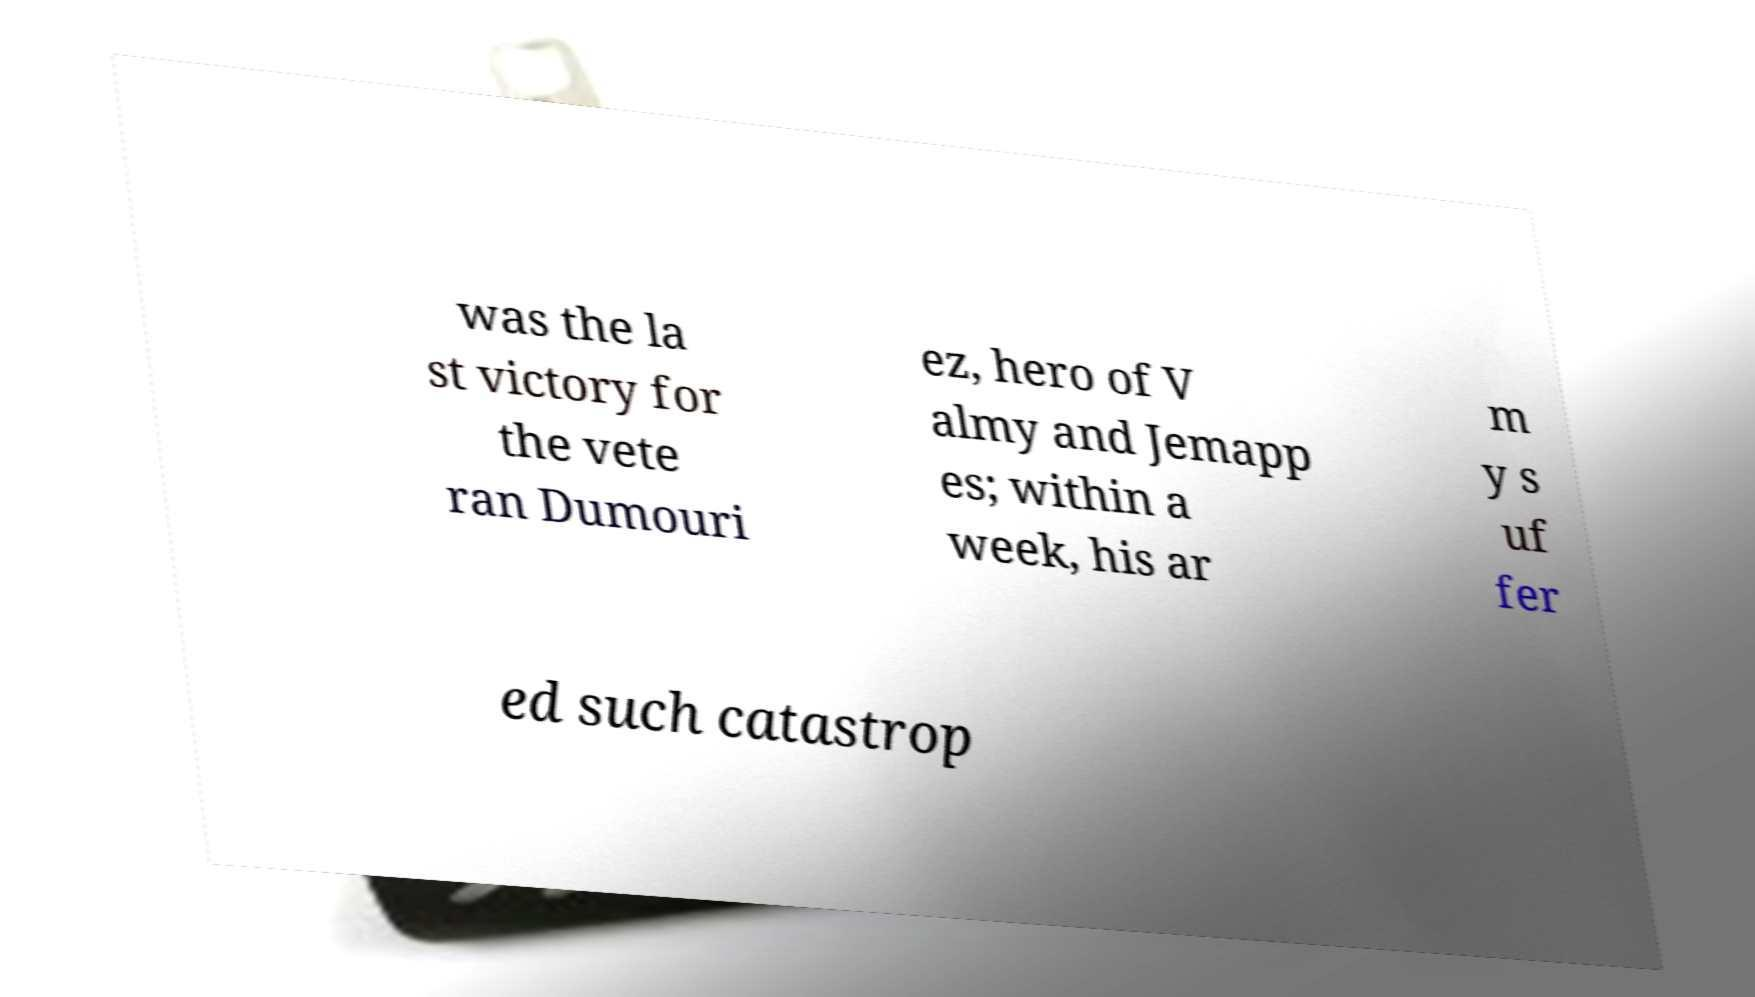Can you accurately transcribe the text from the provided image for me? was the la st victory for the vete ran Dumouri ez, hero of V almy and Jemapp es; within a week, his ar m y s uf fer ed such catastrop 